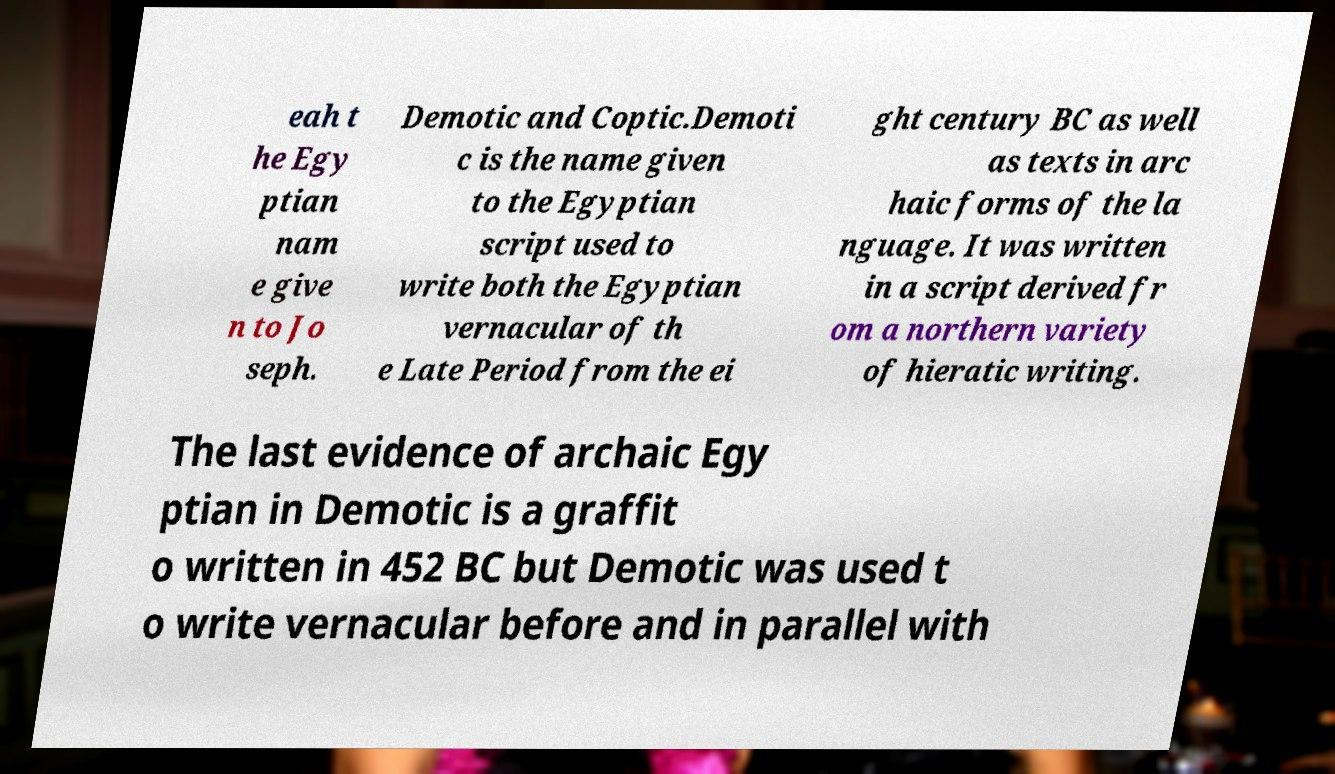There's text embedded in this image that I need extracted. Can you transcribe it verbatim? eah t he Egy ptian nam e give n to Jo seph. Demotic and Coptic.Demoti c is the name given to the Egyptian script used to write both the Egyptian vernacular of th e Late Period from the ei ght century BC as well as texts in arc haic forms of the la nguage. It was written in a script derived fr om a northern variety of hieratic writing. The last evidence of archaic Egy ptian in Demotic is a graffit o written in 452 BC but Demotic was used t o write vernacular before and in parallel with 